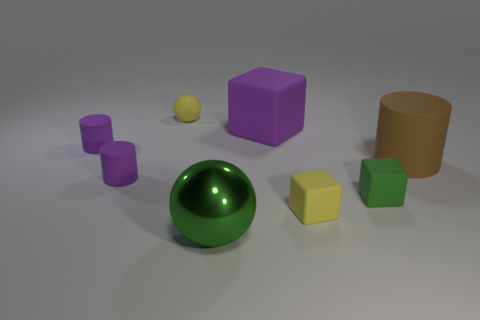Is there a large object that has the same shape as the tiny green object?
Give a very brief answer. Yes. What number of things are matte cylinders that are on the left side of the tiny yellow matte ball or small purple cylinders?
Give a very brief answer. 2. Are there more small matte cubes that are to the left of the green rubber thing than yellow cubes that are on the right side of the small yellow cube?
Offer a very short reply. Yes. How many rubber objects are either tiny purple cylinders or big gray cylinders?
Make the answer very short. 2. There is another object that is the same color as the shiny thing; what is it made of?
Your answer should be compact. Rubber. Is the number of large purple matte objects in front of the green rubber cube less than the number of matte things behind the tiny yellow matte block?
Provide a short and direct response. Yes. What number of objects are either purple objects or yellow matte things that are on the left side of the big green sphere?
Keep it short and to the point. 4. There is a purple object that is the same size as the brown matte cylinder; what is it made of?
Offer a very short reply. Rubber. Is the small yellow ball made of the same material as the large brown thing?
Ensure brevity in your answer.  Yes. There is a thing that is both to the left of the yellow block and in front of the green rubber cube; what is its color?
Keep it short and to the point. Green. 